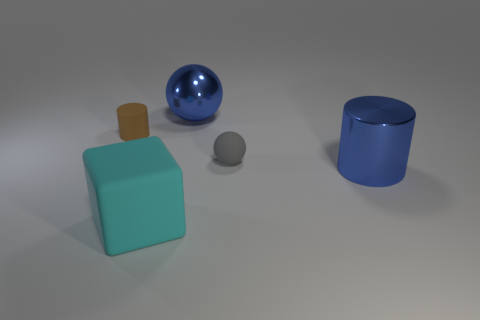What size is the sphere that is the same material as the large blue cylinder?
Keep it short and to the point. Large. What number of blue objects are small matte spheres or metal cylinders?
Make the answer very short. 1. The big metallic object that is the same color as the big cylinder is what shape?
Give a very brief answer. Sphere. There is a shiny thing that is on the left side of the blue metallic cylinder; is its shape the same as the rubber object to the right of the rubber block?
Provide a succinct answer. Yes. What number of big objects are there?
Provide a short and direct response. 3. What is the shape of the gray thing that is the same material as the small brown cylinder?
Offer a very short reply. Sphere. Are there any other things that are the same color as the rubber sphere?
Offer a very short reply. No. There is a big cylinder; is it the same color as the metallic thing that is behind the brown object?
Ensure brevity in your answer.  Yes. Is the number of big matte things right of the big rubber block less than the number of small brown objects?
Your response must be concise. Yes. There is a object on the left side of the matte cube; what material is it?
Your response must be concise. Rubber. 